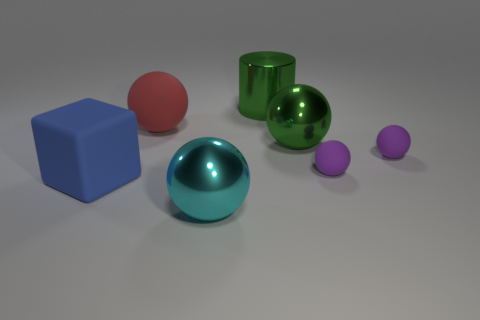Subtract 1 spheres. How many spheres are left? 4 Subtract all green balls. How many balls are left? 4 Subtract all cyan balls. How many balls are left? 4 Subtract all gray blocks. Subtract all green spheres. How many blocks are left? 1 Add 1 large green metal balls. How many objects exist? 8 Subtract all cylinders. How many objects are left? 6 Add 7 tiny cyan metal balls. How many tiny cyan metal balls exist? 7 Subtract 0 yellow balls. How many objects are left? 7 Subtract all large green spheres. Subtract all small gray metallic cubes. How many objects are left? 6 Add 6 purple rubber things. How many purple rubber things are left? 8 